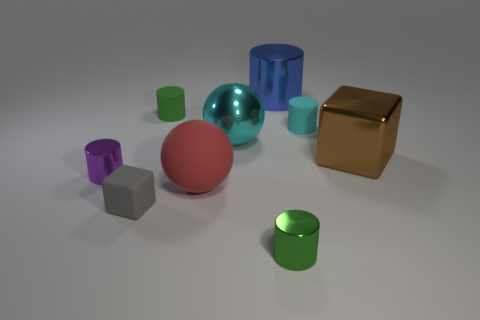Are there any objects that stand out due to their unique properties? Yes, the speherical transparent aqua object stands out for its reflective and transparent qualities, as well as the gold cube for its shiny, metallic texture which differs from the matte finish of the other objects. 